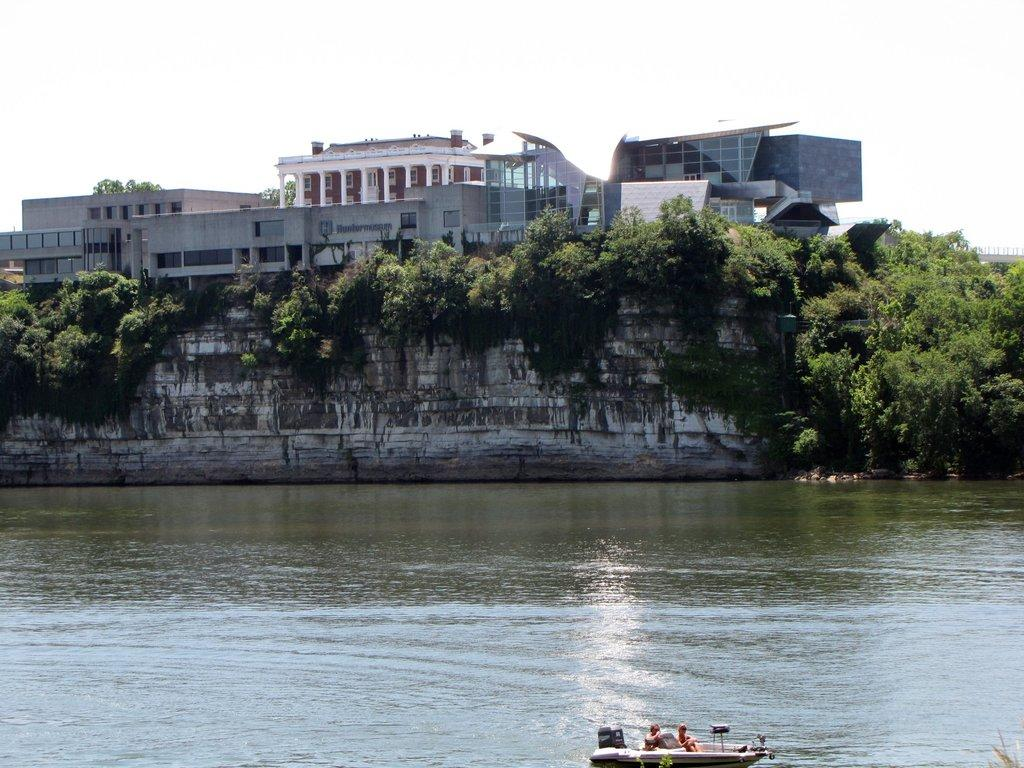What is the main subject of the image? The main subject of the image is a boat. Where is the boat located? The boat is on the water. What other objects or structures can be seen in the image? There are trees and houses in the image. What can be seen in the background of the image? The sky is visible in the background of the image. Can you tell me how many zebras are swimming alongside the boat in the image? There are no zebras present in the image; it features a boat on the water with trees and houses in the background. What type of destruction can be seen happening to the houses in the image? There is no destruction visible in the image; the houses appear to be intact. 